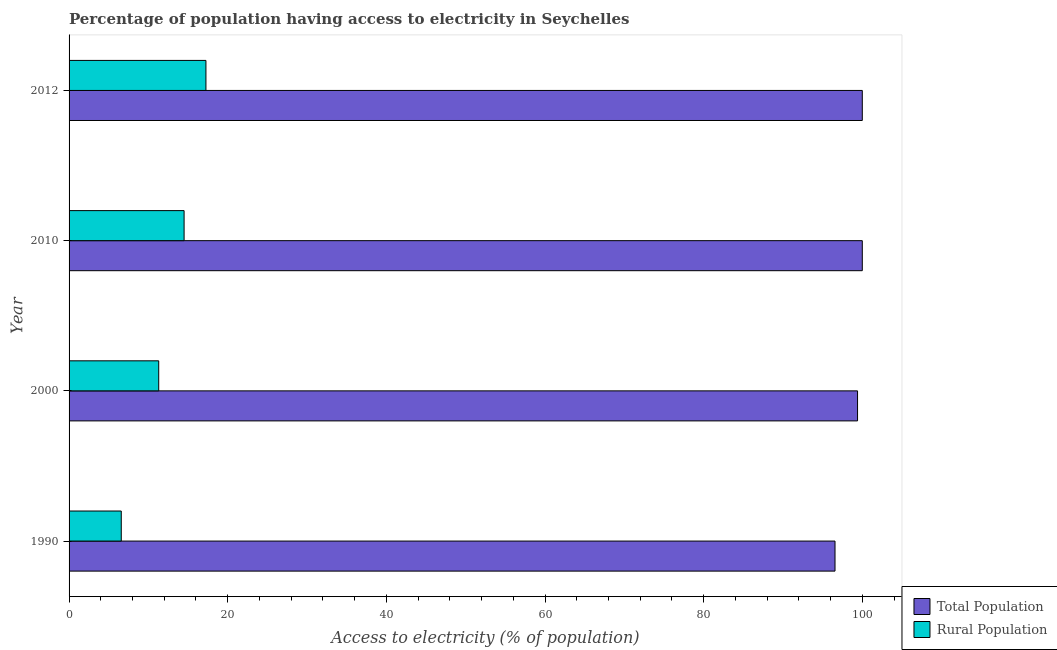Are the number of bars per tick equal to the number of legend labels?
Make the answer very short. Yes. Are the number of bars on each tick of the Y-axis equal?
Your answer should be very brief. Yes. How many bars are there on the 2nd tick from the top?
Offer a very short reply. 2. What is the label of the 2nd group of bars from the top?
Ensure brevity in your answer.  2010. What is the percentage of rural population having access to electricity in 2010?
Your answer should be very brief. 14.5. Across all years, what is the maximum percentage of rural population having access to electricity?
Make the answer very short. 17.25. Across all years, what is the minimum percentage of rural population having access to electricity?
Offer a terse response. 6.58. In which year was the percentage of rural population having access to electricity maximum?
Keep it short and to the point. 2012. What is the total percentage of population having access to electricity in the graph?
Keep it short and to the point. 395.96. What is the difference between the percentage of rural population having access to electricity in 1990 and that in 2010?
Provide a short and direct response. -7.92. What is the difference between the percentage of rural population having access to electricity in 2012 and the percentage of population having access to electricity in 1990?
Offer a terse response. -79.31. What is the average percentage of rural population having access to electricity per year?
Offer a very short reply. 12.41. In the year 2012, what is the difference between the percentage of rural population having access to electricity and percentage of population having access to electricity?
Give a very brief answer. -82.75. What is the ratio of the percentage of population having access to electricity in 1990 to that in 2000?
Your response must be concise. 0.97. What is the difference between the highest and the second highest percentage of rural population having access to electricity?
Your answer should be very brief. 2.75. What is the difference between the highest and the lowest percentage of rural population having access to electricity?
Provide a succinct answer. 10.68. What does the 2nd bar from the top in 2010 represents?
Provide a short and direct response. Total Population. What does the 1st bar from the bottom in 1990 represents?
Offer a very short reply. Total Population. Are all the bars in the graph horizontal?
Your response must be concise. Yes. What is the difference between two consecutive major ticks on the X-axis?
Offer a terse response. 20. Are the values on the major ticks of X-axis written in scientific E-notation?
Keep it short and to the point. No. Where does the legend appear in the graph?
Provide a short and direct response. Bottom right. How are the legend labels stacked?
Provide a short and direct response. Vertical. What is the title of the graph?
Keep it short and to the point. Percentage of population having access to electricity in Seychelles. What is the label or title of the X-axis?
Give a very brief answer. Access to electricity (% of population). What is the Access to electricity (% of population) in Total Population in 1990?
Make the answer very short. 96.56. What is the Access to electricity (% of population) of Rural Population in 1990?
Offer a very short reply. 6.58. What is the Access to electricity (% of population) in Total Population in 2000?
Provide a succinct answer. 99.4. What is the Access to electricity (% of population) in Rural Population in 2000?
Provide a succinct answer. 11.3. What is the Access to electricity (% of population) of Total Population in 2010?
Provide a short and direct response. 100. What is the Access to electricity (% of population) in Total Population in 2012?
Ensure brevity in your answer.  100. What is the Access to electricity (% of population) of Rural Population in 2012?
Your answer should be very brief. 17.25. Across all years, what is the maximum Access to electricity (% of population) of Total Population?
Ensure brevity in your answer.  100. Across all years, what is the maximum Access to electricity (% of population) in Rural Population?
Provide a succinct answer. 17.25. Across all years, what is the minimum Access to electricity (% of population) in Total Population?
Your answer should be very brief. 96.56. Across all years, what is the minimum Access to electricity (% of population) in Rural Population?
Keep it short and to the point. 6.58. What is the total Access to electricity (% of population) of Total Population in the graph?
Provide a succinct answer. 395.96. What is the total Access to electricity (% of population) of Rural Population in the graph?
Your answer should be compact. 49.64. What is the difference between the Access to electricity (% of population) in Total Population in 1990 and that in 2000?
Keep it short and to the point. -2.84. What is the difference between the Access to electricity (% of population) in Rural Population in 1990 and that in 2000?
Your answer should be compact. -4.72. What is the difference between the Access to electricity (% of population) of Total Population in 1990 and that in 2010?
Offer a very short reply. -3.44. What is the difference between the Access to electricity (% of population) in Rural Population in 1990 and that in 2010?
Offer a very short reply. -7.92. What is the difference between the Access to electricity (% of population) of Total Population in 1990 and that in 2012?
Your response must be concise. -3.44. What is the difference between the Access to electricity (% of population) in Rural Population in 1990 and that in 2012?
Keep it short and to the point. -10.68. What is the difference between the Access to electricity (% of population) of Rural Population in 2000 and that in 2010?
Ensure brevity in your answer.  -3.2. What is the difference between the Access to electricity (% of population) in Total Population in 2000 and that in 2012?
Provide a short and direct response. -0.6. What is the difference between the Access to electricity (% of population) of Rural Population in 2000 and that in 2012?
Keep it short and to the point. -5.95. What is the difference between the Access to electricity (% of population) of Rural Population in 2010 and that in 2012?
Offer a terse response. -2.75. What is the difference between the Access to electricity (% of population) of Total Population in 1990 and the Access to electricity (% of population) of Rural Population in 2000?
Your response must be concise. 85.26. What is the difference between the Access to electricity (% of population) in Total Population in 1990 and the Access to electricity (% of population) in Rural Population in 2010?
Your response must be concise. 82.06. What is the difference between the Access to electricity (% of population) of Total Population in 1990 and the Access to electricity (% of population) of Rural Population in 2012?
Offer a terse response. 79.31. What is the difference between the Access to electricity (% of population) in Total Population in 2000 and the Access to electricity (% of population) in Rural Population in 2010?
Give a very brief answer. 84.9. What is the difference between the Access to electricity (% of population) of Total Population in 2000 and the Access to electricity (% of population) of Rural Population in 2012?
Your answer should be compact. 82.15. What is the difference between the Access to electricity (% of population) of Total Population in 2010 and the Access to electricity (% of population) of Rural Population in 2012?
Make the answer very short. 82.75. What is the average Access to electricity (% of population) of Total Population per year?
Offer a terse response. 98.99. What is the average Access to electricity (% of population) of Rural Population per year?
Your answer should be very brief. 12.41. In the year 1990, what is the difference between the Access to electricity (% of population) in Total Population and Access to electricity (% of population) in Rural Population?
Offer a terse response. 89.98. In the year 2000, what is the difference between the Access to electricity (% of population) in Total Population and Access to electricity (% of population) in Rural Population?
Your answer should be compact. 88.1. In the year 2010, what is the difference between the Access to electricity (% of population) in Total Population and Access to electricity (% of population) in Rural Population?
Ensure brevity in your answer.  85.5. In the year 2012, what is the difference between the Access to electricity (% of population) of Total Population and Access to electricity (% of population) of Rural Population?
Offer a terse response. 82.75. What is the ratio of the Access to electricity (% of population) of Total Population in 1990 to that in 2000?
Offer a terse response. 0.97. What is the ratio of the Access to electricity (% of population) of Rural Population in 1990 to that in 2000?
Keep it short and to the point. 0.58. What is the ratio of the Access to electricity (% of population) in Total Population in 1990 to that in 2010?
Your answer should be compact. 0.97. What is the ratio of the Access to electricity (% of population) in Rural Population in 1990 to that in 2010?
Make the answer very short. 0.45. What is the ratio of the Access to electricity (% of population) of Total Population in 1990 to that in 2012?
Provide a short and direct response. 0.97. What is the ratio of the Access to electricity (% of population) in Rural Population in 1990 to that in 2012?
Your answer should be compact. 0.38. What is the ratio of the Access to electricity (% of population) in Rural Population in 2000 to that in 2010?
Offer a terse response. 0.78. What is the ratio of the Access to electricity (% of population) of Rural Population in 2000 to that in 2012?
Keep it short and to the point. 0.66. What is the ratio of the Access to electricity (% of population) of Total Population in 2010 to that in 2012?
Make the answer very short. 1. What is the ratio of the Access to electricity (% of population) of Rural Population in 2010 to that in 2012?
Provide a short and direct response. 0.84. What is the difference between the highest and the second highest Access to electricity (% of population) in Total Population?
Your response must be concise. 0. What is the difference between the highest and the second highest Access to electricity (% of population) in Rural Population?
Your response must be concise. 2.75. What is the difference between the highest and the lowest Access to electricity (% of population) in Total Population?
Your answer should be compact. 3.44. What is the difference between the highest and the lowest Access to electricity (% of population) of Rural Population?
Offer a very short reply. 10.68. 